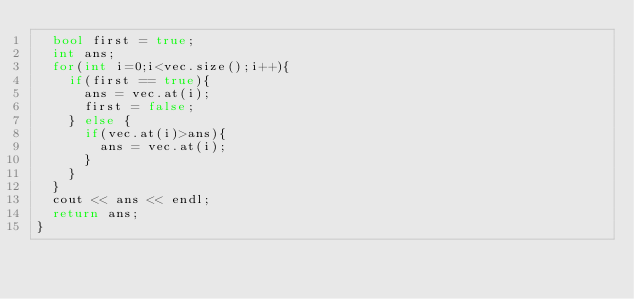Convert code to text. <code><loc_0><loc_0><loc_500><loc_500><_C++_>  bool first = true;
  int ans;
  for(int i=0;i<vec.size();i++){
    if(first == true){
      ans = vec.at(i);
      first = false;
    } else {
      if(vec.at(i)>ans){
        ans = vec.at(i);
      }
    }
  }
  cout << ans << endl;
  return ans;
}</code> 